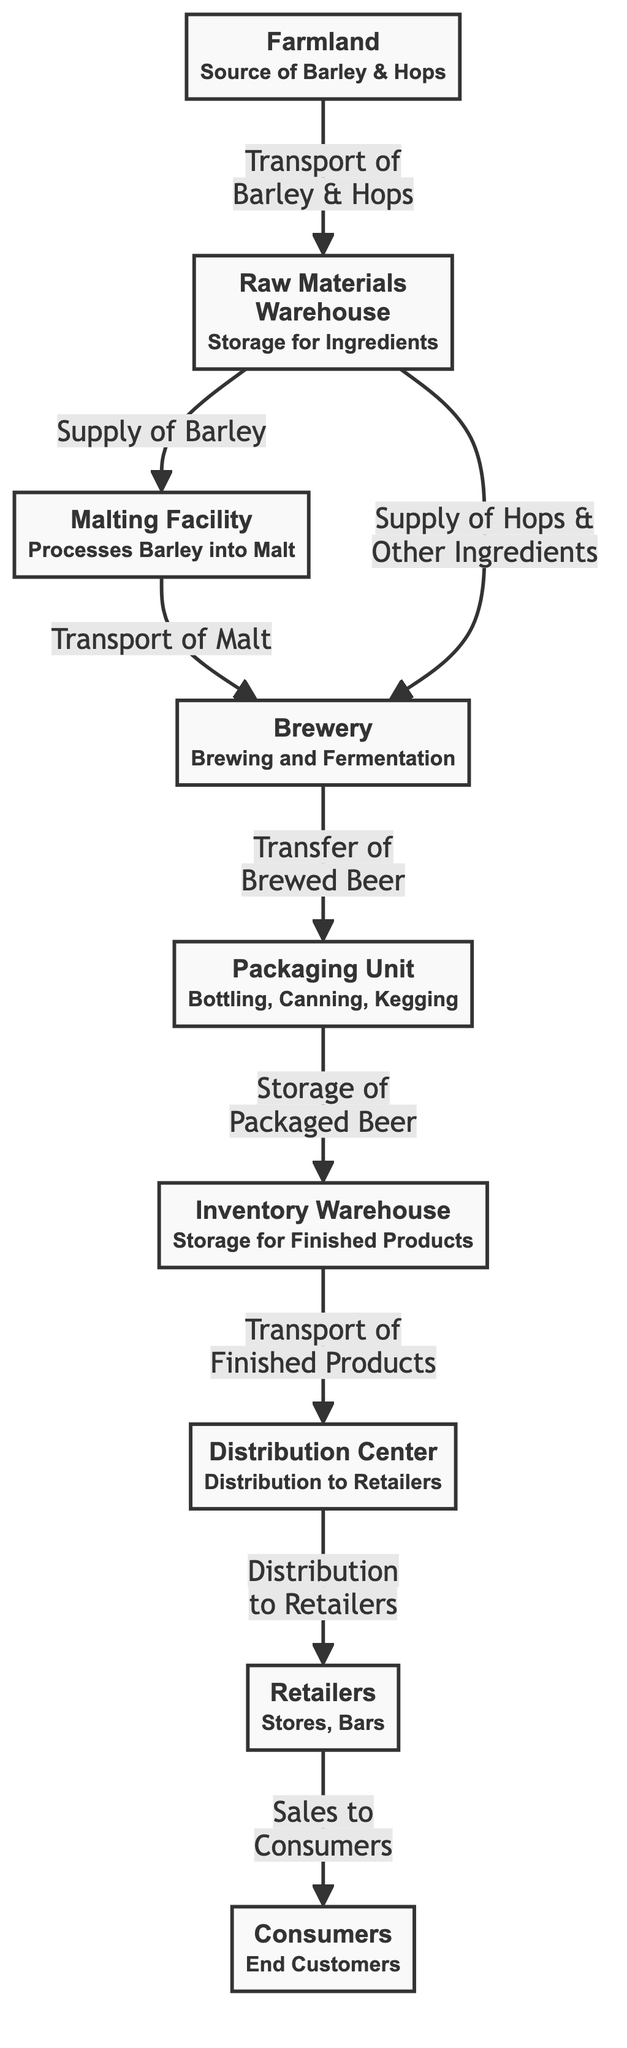What is the source of Barley and Hops? The diagram indicates that the source of Barley and Hops is the "Farmland" node. Thus, the basic information depicted shows that these ingredients originate from the farmland.
Answer: Farmland How many main steps are there in the supply chain? The diagram lists eight nodes that represent different stages in the supply chain: Farmland, Raw Materials Warehouse, Malting Facility, Brewery, Packaging Unit, Inventory Warehouse, Distribution Center, and Retailers. Counting these nodes provides the answer.
Answer: 8 What is transported from the malting facility to the brewery? The diagram specifies that "Malt" is transported from the "Malting Facility" to the "Brewery." This relationship is clearly indicated within the flow of the diagram, showing the processing of barley into malt.
Answer: Malt What type of facility processes barley into malt? By examining the diagram, it is clear that the "Malting Facility" is responsible for processing barley into malt, showcasing its essential role in the brewing process.
Answer: Malting Facility Where do breweries send their packaged beer? The diagram shows that after the brewing process, the "Brewery" transfers "Brewed Beer" to the "Packaging Unit." This indicates the next step in the supply chain focusing on the transition of products.
Answer: Packaging Unit What is stored in the inventory warehouse? According to the diagram, the "Inventory Warehouse" stores "Finished Products," which means that this facility maintains the completed products before they are distributed.
Answer: Finished Products What do retailers do? The diagram indicates that retailers engage in "Sales to Consumers," illustrating their role in selling the products to the end customers after receiving them from the distribution center.
Answer: Sales to Consumers What is the role of the distribution center? The flowchart depicts that the "Distribution Center" is involved in the "Distribution to Retailers." This is a crucial function to ensure that products reach stores and bars for consumer access.
Answer: Distribution to Retailers What is the connection between the raw materials warehouse and the brewery? The diagram shows two connections from the "Raw Materials Warehouse" to the "Brewery," which includes the supply of "Barley" for malt processing and the supply of "Hops & Other Ingredients." This relationship illustrates the input flow into brewing.
Answer: Supply of Barley & Hops & Other Ingredients 